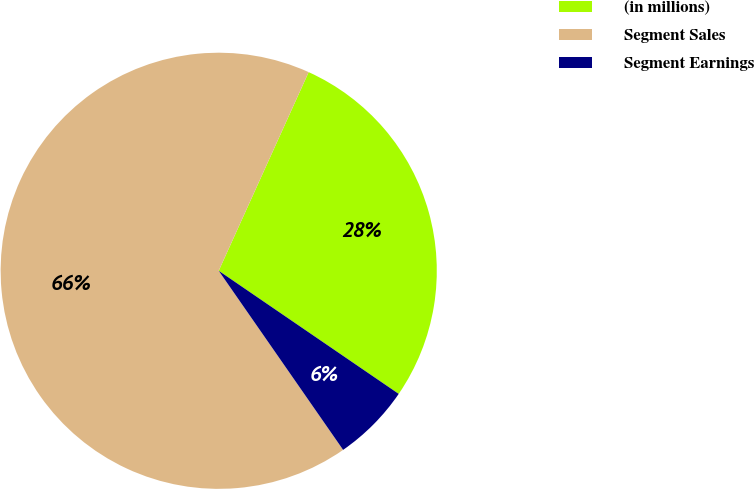Convert chart to OTSL. <chart><loc_0><loc_0><loc_500><loc_500><pie_chart><fcel>(in millions)<fcel>Segment Sales<fcel>Segment Earnings<nl><fcel>27.78%<fcel>66.43%<fcel>5.79%<nl></chart> 